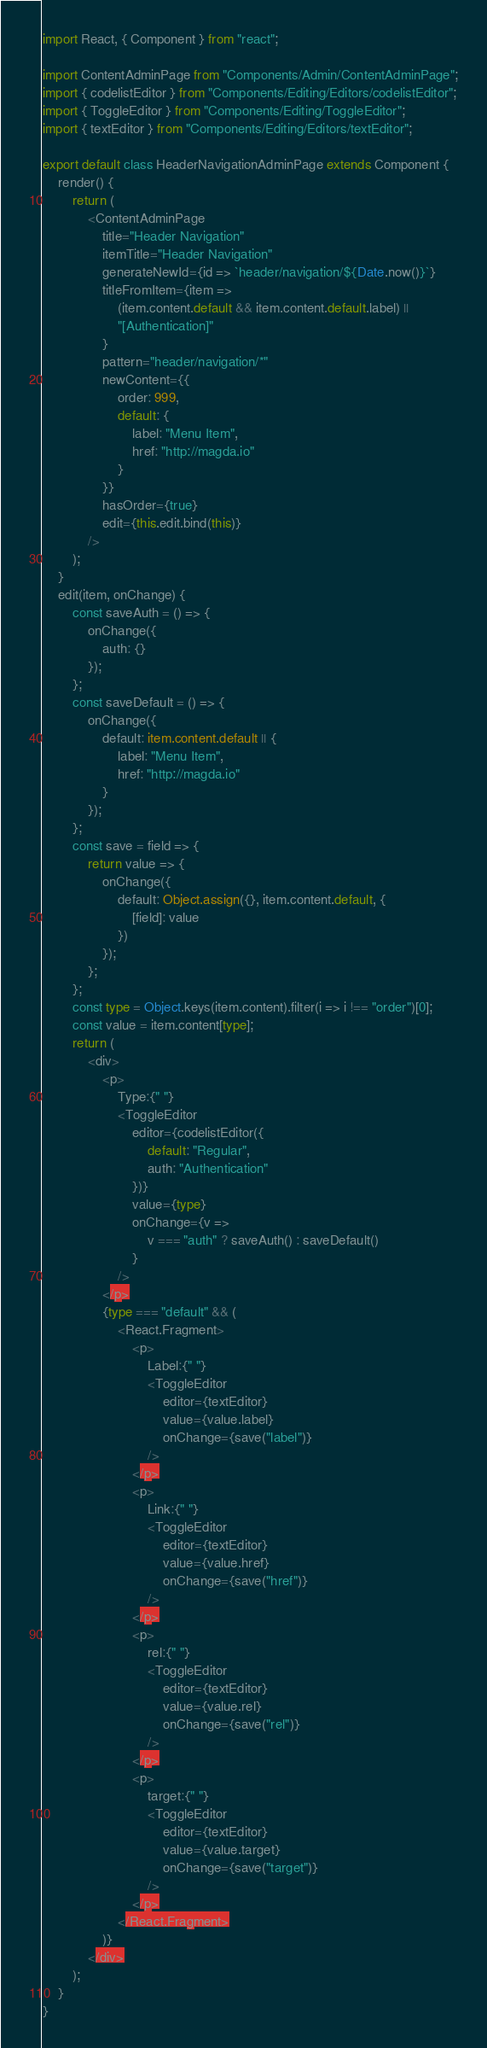<code> <loc_0><loc_0><loc_500><loc_500><_TypeScript_>import React, { Component } from "react";

import ContentAdminPage from "Components/Admin/ContentAdminPage";
import { codelistEditor } from "Components/Editing/Editors/codelistEditor";
import { ToggleEditor } from "Components/Editing/ToggleEditor";
import { textEditor } from "Components/Editing/Editors/textEditor";

export default class HeaderNavigationAdminPage extends Component {
    render() {
        return (
            <ContentAdminPage
                title="Header Navigation"
                itemTitle="Header Navigation"
                generateNewId={id => `header/navigation/${Date.now()}`}
                titleFromItem={item =>
                    (item.content.default && item.content.default.label) ||
                    "[Authentication]"
                }
                pattern="header/navigation/*"
                newContent={{
                    order: 999,
                    default: {
                        label: "Menu Item",
                        href: "http://magda.io"
                    }
                }}
                hasOrder={true}
                edit={this.edit.bind(this)}
            />
        );
    }
    edit(item, onChange) {
        const saveAuth = () => {
            onChange({
                auth: {}
            });
        };
        const saveDefault = () => {
            onChange({
                default: item.content.default || {
                    label: "Menu Item",
                    href: "http://magda.io"
                }
            });
        };
        const save = field => {
            return value => {
                onChange({
                    default: Object.assign({}, item.content.default, {
                        [field]: value
                    })
                });
            };
        };
        const type = Object.keys(item.content).filter(i => i !== "order")[0];
        const value = item.content[type];
        return (
            <div>
                <p>
                    Type:{" "}
                    <ToggleEditor
                        editor={codelistEditor({
                            default: "Regular",
                            auth: "Authentication"
                        })}
                        value={type}
                        onChange={v =>
                            v === "auth" ? saveAuth() : saveDefault()
                        }
                    />
                </p>
                {type === "default" && (
                    <React.Fragment>
                        <p>
                            Label:{" "}
                            <ToggleEditor
                                editor={textEditor}
                                value={value.label}
                                onChange={save("label")}
                            />
                        </p>
                        <p>
                            Link:{" "}
                            <ToggleEditor
                                editor={textEditor}
                                value={value.href}
                                onChange={save("href")}
                            />
                        </p>
                        <p>
                            rel:{" "}
                            <ToggleEditor
                                editor={textEditor}
                                value={value.rel}
                                onChange={save("rel")}
                            />
                        </p>
                        <p>
                            target:{" "}
                            <ToggleEditor
                                editor={textEditor}
                                value={value.target}
                                onChange={save("target")}
                            />
                        </p>
                    </React.Fragment>
                )}
            </div>
        );
    }
}
</code> 